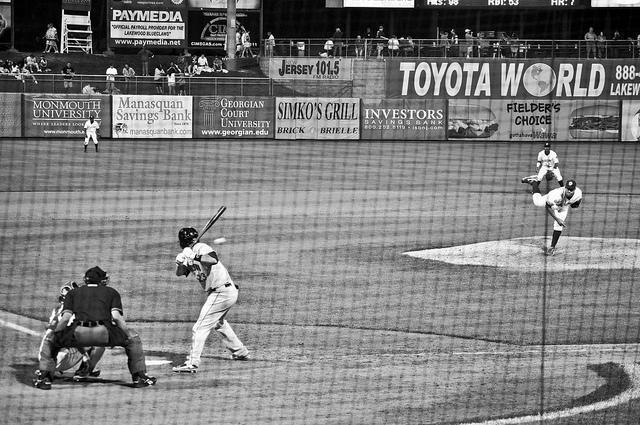How many people are there?
Give a very brief answer. 3. 